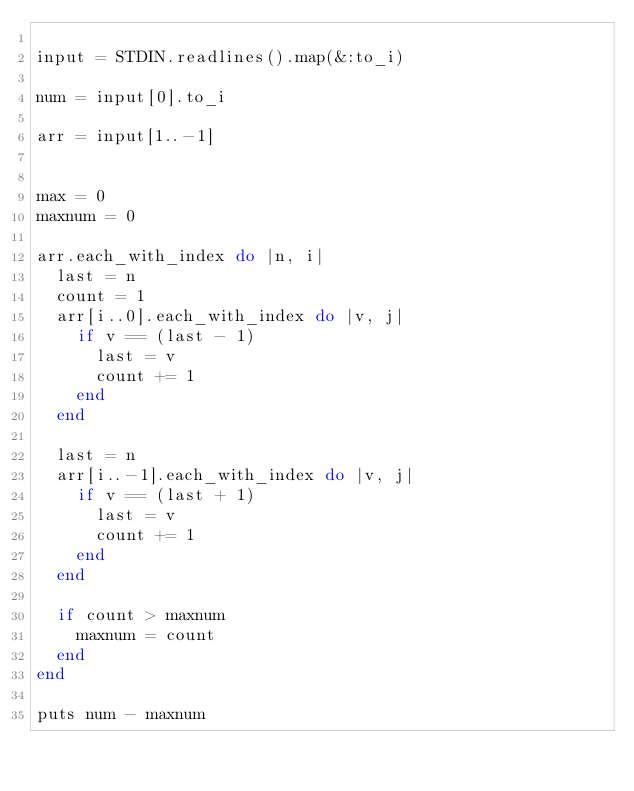Convert code to text. <code><loc_0><loc_0><loc_500><loc_500><_Ruby_>
input = STDIN.readlines().map(&:to_i)

num = input[0].to_i

arr = input[1..-1]


max = 0
maxnum = 0

arr.each_with_index do |n, i|
  last = n
  count = 1
  arr[i..0].each_with_index do |v, j|
    if v == (last - 1)
      last = v
      count += 1
    end
  end

  last = n
  arr[i..-1].each_with_index do |v, j|
    if v == (last + 1)
      last = v
      count += 1
    end
  end

  if count > maxnum
    maxnum = count
  end
end

puts num - maxnum
</code> 